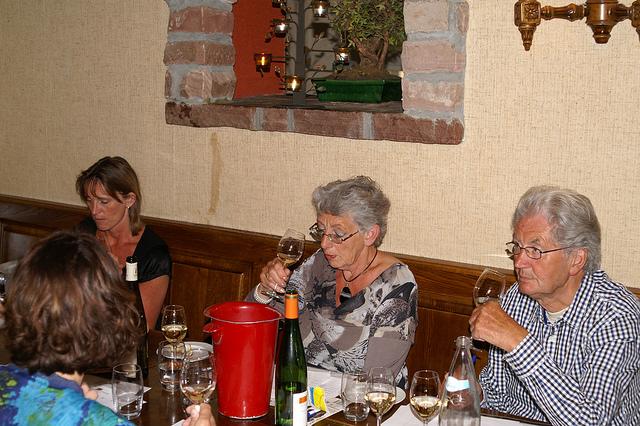Is this a wine tasting event?
Answer briefly. Yes. How many elderly people are at the table?
Quick response, please. 2. Which people are holding cups?
Quick response, please. Elderly people. 